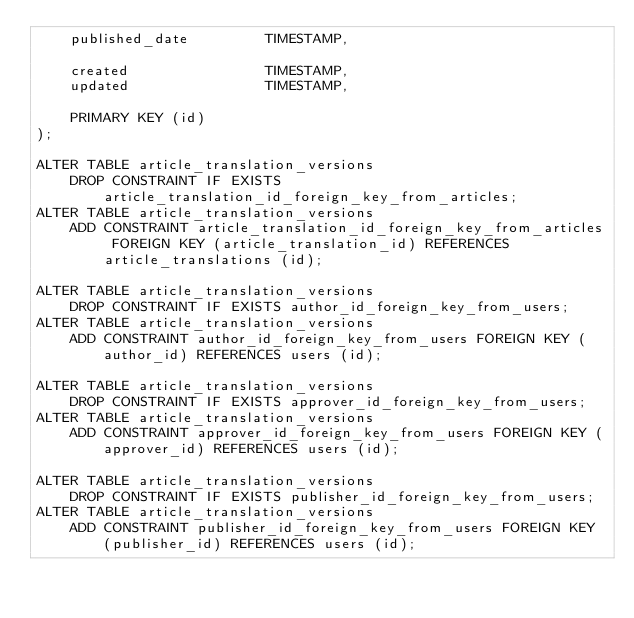<code> <loc_0><loc_0><loc_500><loc_500><_SQL_>    published_date         TIMESTAMP,

    created                TIMESTAMP,
    updated                TIMESTAMP,

    PRIMARY KEY (id)
);

ALTER TABLE article_translation_versions
    DROP CONSTRAINT IF EXISTS article_translation_id_foreign_key_from_articles;
ALTER TABLE article_translation_versions
    ADD CONSTRAINT article_translation_id_foreign_key_from_articles FOREIGN KEY (article_translation_id) REFERENCES article_translations (id);

ALTER TABLE article_translation_versions
    DROP CONSTRAINT IF EXISTS author_id_foreign_key_from_users;
ALTER TABLE article_translation_versions
    ADD CONSTRAINT author_id_foreign_key_from_users FOREIGN KEY (author_id) REFERENCES users (id);

ALTER TABLE article_translation_versions
    DROP CONSTRAINT IF EXISTS approver_id_foreign_key_from_users;
ALTER TABLE article_translation_versions
    ADD CONSTRAINT approver_id_foreign_key_from_users FOREIGN KEY (approver_id) REFERENCES users (id);

ALTER TABLE article_translation_versions
    DROP CONSTRAINT IF EXISTS publisher_id_foreign_key_from_users;
ALTER TABLE article_translation_versions
    ADD CONSTRAINT publisher_id_foreign_key_from_users FOREIGN KEY (publisher_id) REFERENCES users (id);</code> 